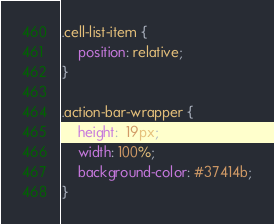<code> <loc_0><loc_0><loc_500><loc_500><_CSS_>.cell-list-item {
    position: relative;
}

.action-bar-wrapper {
    height:  19px;
    width: 100%;
    background-color: #37414b;
}</code> 